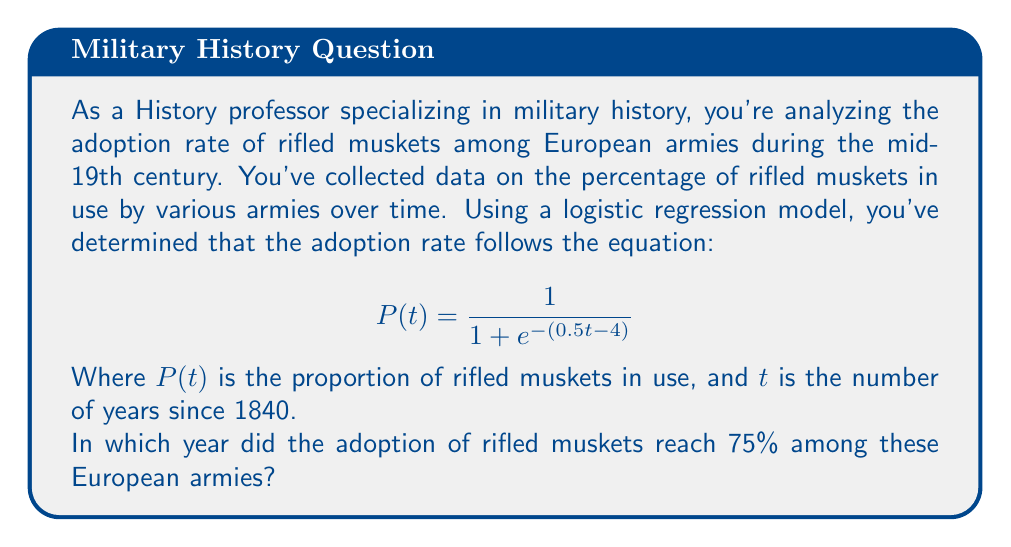Solve this math problem. To solve this problem, we'll follow these steps:

1) We're looking for the year when $P(t) = 0.75$, or 75%.

2) Let's substitute this into our logistic regression equation:

   $$0.75 = \frac{1}{1 + e^{-(0.5t - 4)}}$$

3) Now, let's solve this equation for $t$:
   
   $$1 + e^{-(0.5t - 4)} = \frac{1}{0.75}$$
   
   $$e^{-(0.5t - 4)} = \frac{1}{0.75} - 1 = \frac{4}{3} - 1 = \frac{1}{3}$$

4) Taking the natural log of both sides:

   $$-(0.5t - 4) = \ln(\frac{1}{3})$$

5) Multiply both sides by -1:

   $$0.5t - 4 = -\ln(\frac{1}{3})$$

6) Add 4 to both sides:

   $$0.5t = 4 - \ln(\frac{1}{3})$$

7) Multiply both sides by 2:

   $$t = 8 - 2\ln(\frac{1}{3}) \approx 10.2$$

8) Since $t$ represents the number of years since 1840, we add 1840 to our result:

   1840 + 10.2 ≈ 1850.2

9) Rounding to the nearest year, we get 1850.
Answer: 1850 